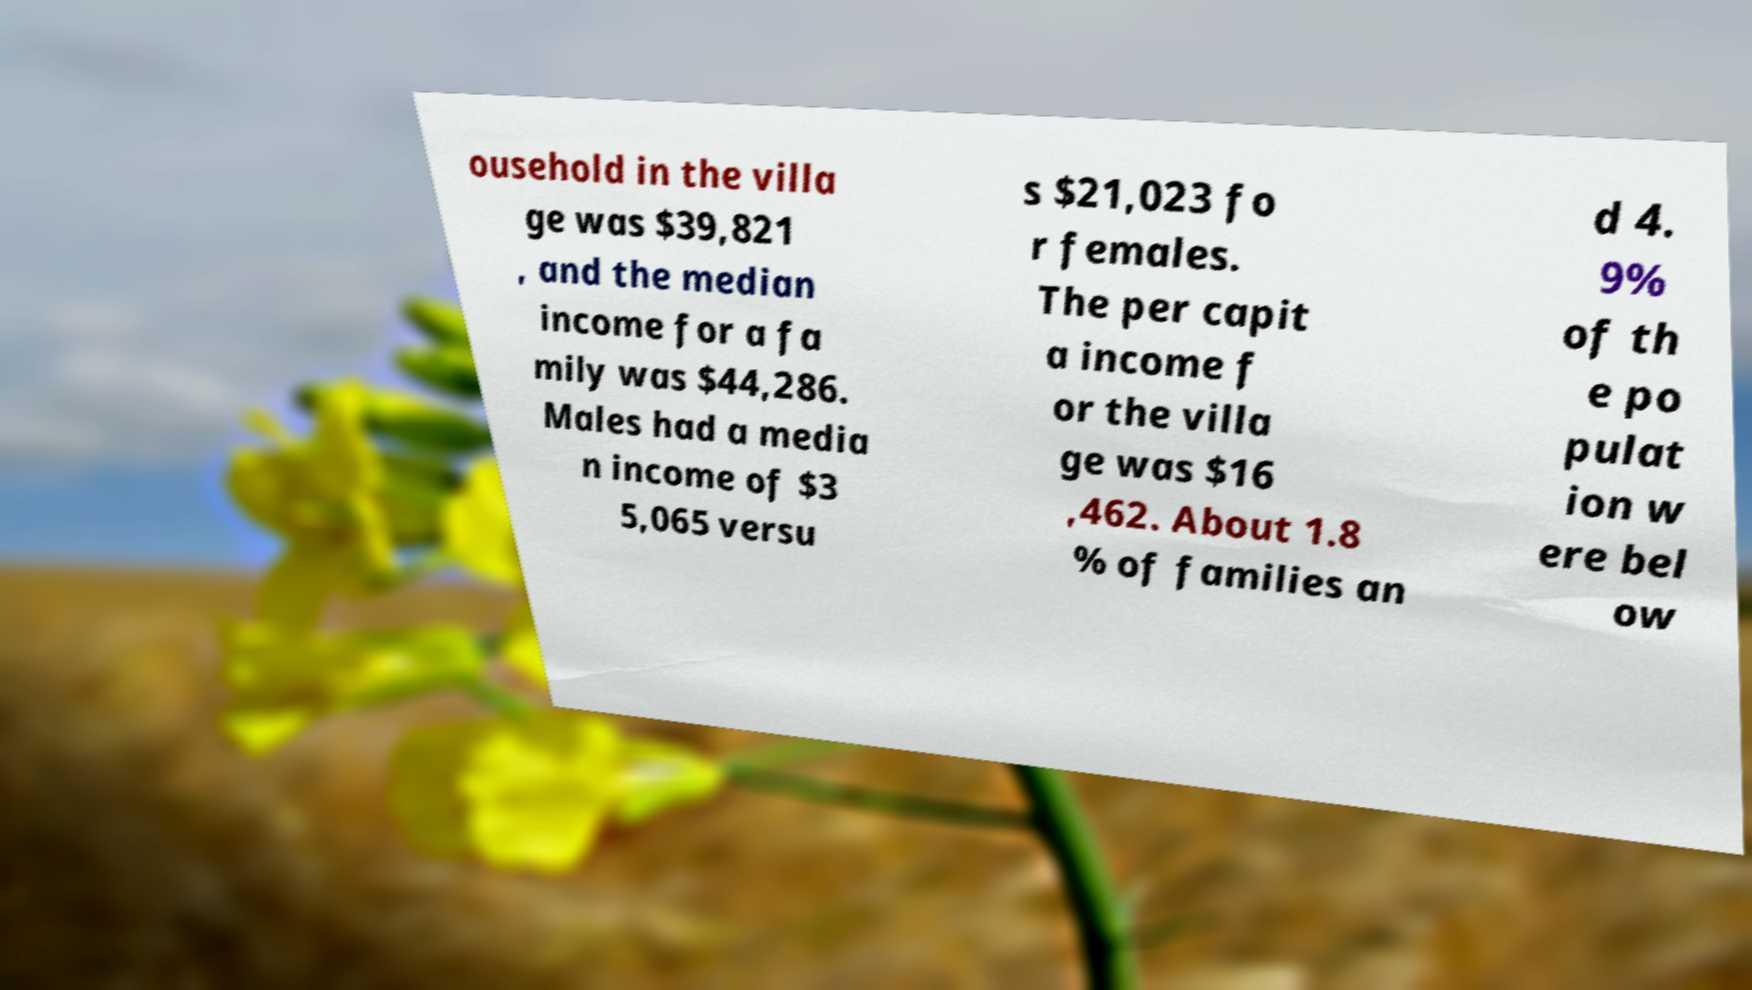Please identify and transcribe the text found in this image. ousehold in the villa ge was $39,821 , and the median income for a fa mily was $44,286. Males had a media n income of $3 5,065 versu s $21,023 fo r females. The per capit a income f or the villa ge was $16 ,462. About 1.8 % of families an d 4. 9% of th e po pulat ion w ere bel ow 